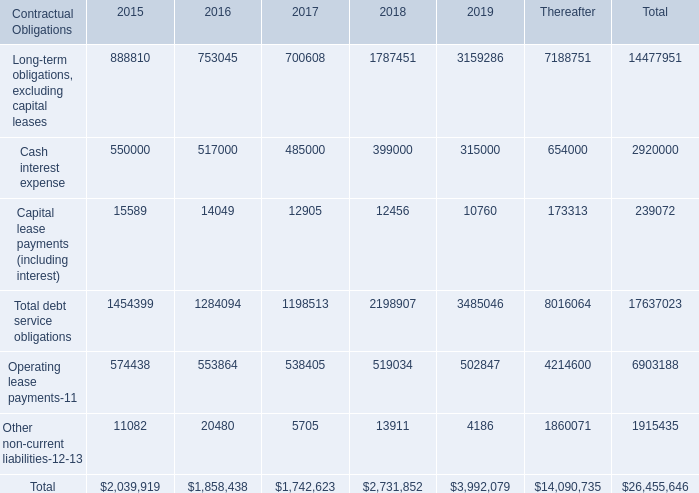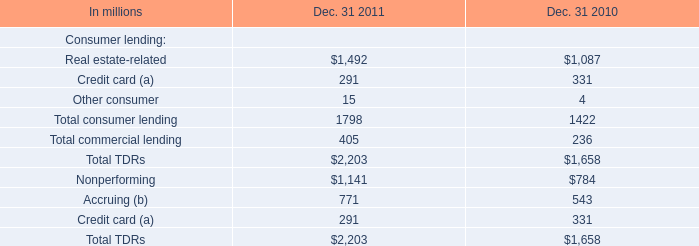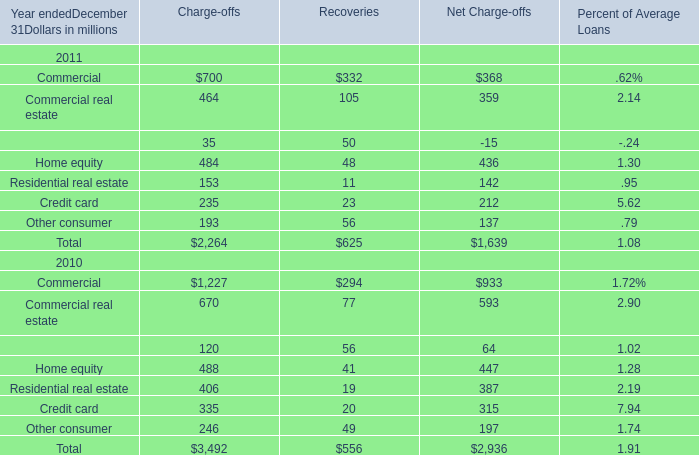In the year with largest amount of home equity for recoveries what's the increasing rate of credit card? (in %) 
Computations: ((23 - 20) / 20)
Answer: 0.15. 